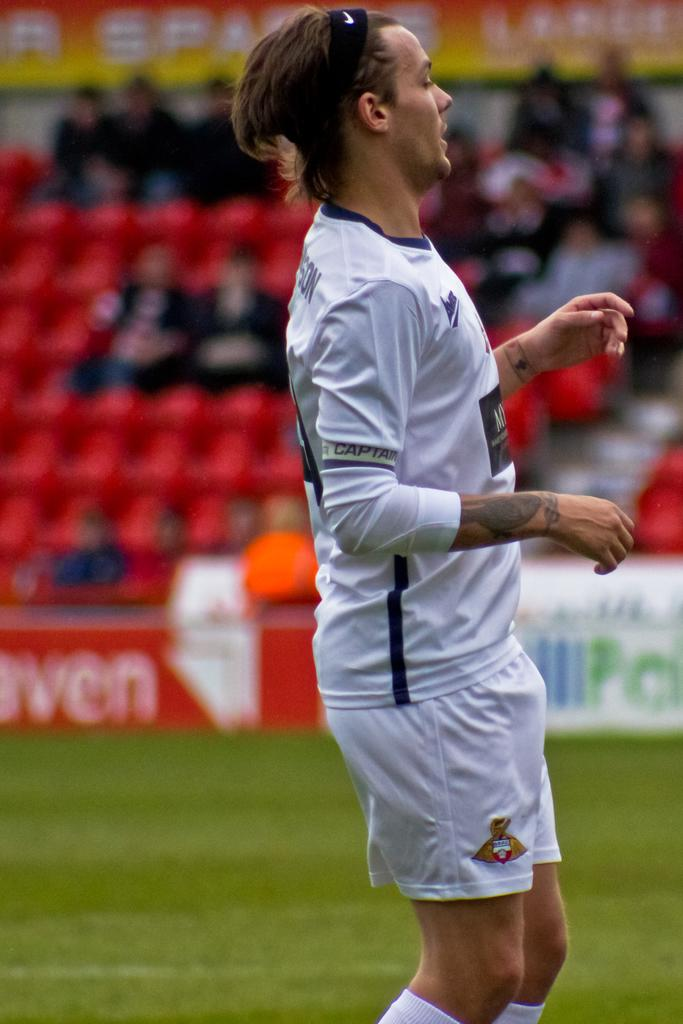What is the main subject in the center of the image? There is a man standing in the center of the image. What can be seen in the background of the image? There are chairs, people, and a board in the background of the image. What is visible at the bottom of the image? The ground is visible at the bottom of the image. What type of soap is the man holding in the image? There is no soap present in the image; the man is not holding anything. 